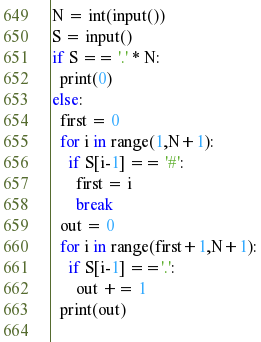Convert code to text. <code><loc_0><loc_0><loc_500><loc_500><_Python_>N = int(input())
S = input()
if S == '.' * N:
  print(0)
else:
  first = 0
  for i in range(1,N+1):
    if S[i-1] == '#':
      first = i
      break
  out = 0
  for i in range(first+1,N+1):
    if S[i-1] =='.':
      out += 1
  print(out)
    </code> 